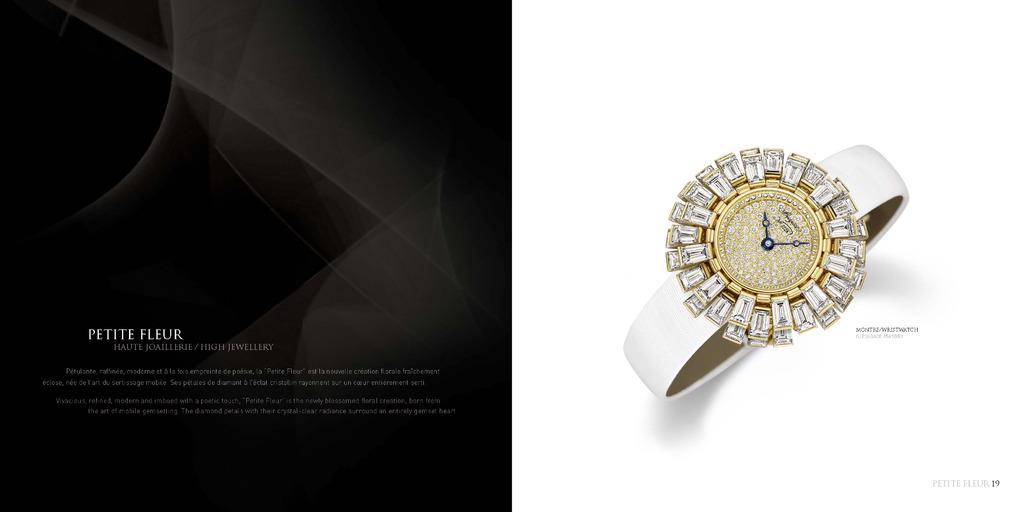What is the brand of this watch?
Your answer should be very brief. Petite fleur. This dimond ring watch?
Your response must be concise. Yes. 